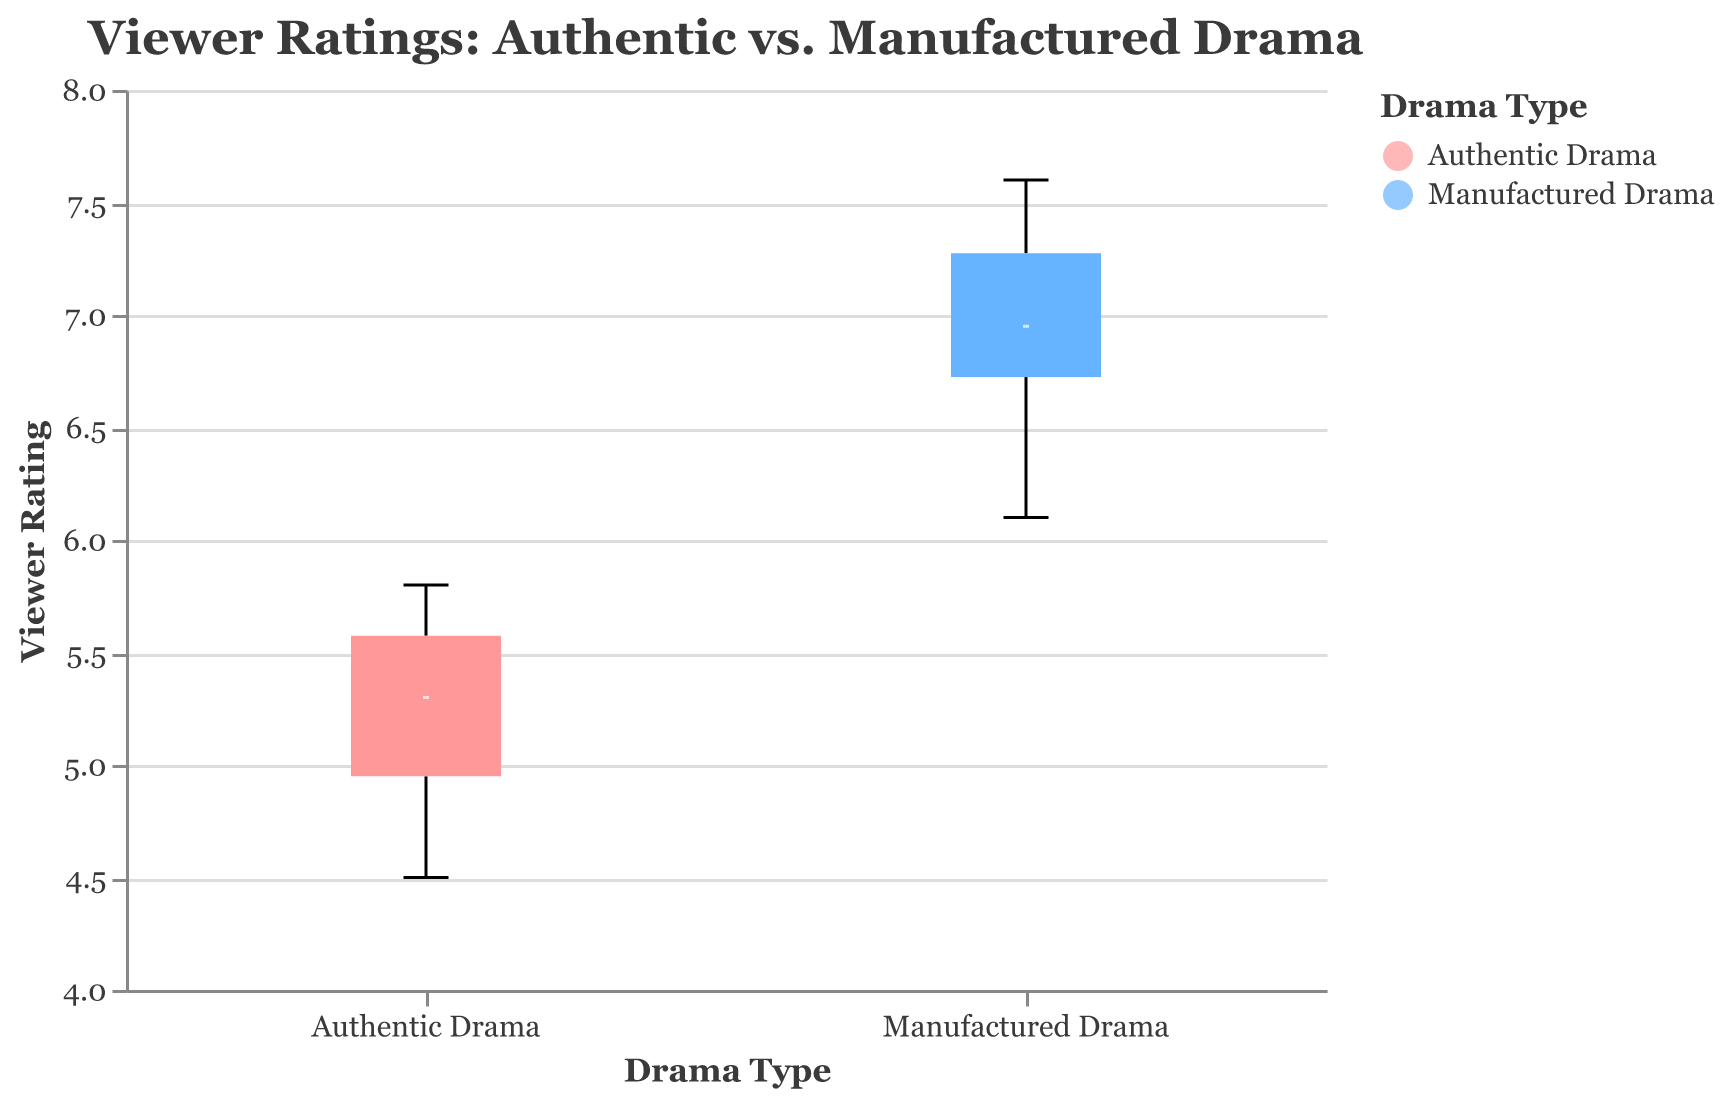What's the title of the box plot? The title is located at the top of the visualization.
Answer: Viewer Ratings: Authentic vs. Manufactured Drama What do the colors in the box plot represent? The legend indicates that the colors differentiate between "Authentic Drama" and "Manufactured Drama".
Answer: The colors represent "Authentic Drama" and "Manufactured Drama" Which group has the higher median viewer rating? The box plot's median lines represent this information. The median line for "Manufactured Drama" is higher than that for "Authentic Drama".
Answer: "Manufactured Drama" What's the minimum viewer rating for episodes featuring authentic drama? The minimum viewer rating is the lowest end of the whisker for "Authentic Drama".
Answer: 4.5 Which group shows a larger spread in viewer ratings? The spread is determined by the range from the minimum to maximum values in the box plots. "Manufactured Drama" has a wider range.
Answer: "Manufactured Drama" What is the interquartile range (IQR) for episodes featuring manufactured drama? The IQR is the range between the first quartile and third quartile in the box plot for "Manufactured Drama". The exact values can be estimated from the plot.
Answer: Approximately 1.9 (from ~6.4 to ~8.3) How do the maximum viewer ratings compare between the two drama types? The maximum viewer ratings are represented by the top ends of the whiskers. "Manufactured Drama" has a higher maximum than "Authentic Drama".
Answer: "Manufactured Drama" has a higher maximum What does the difference between the median viewer ratings of the two groups indicate about viewer preferences? The medians suggest that "Manufactured Drama" tends to have higher ratings on average, possibly indicating a preference for this type of drama.
Answer: Viewer preference leans towards "Manufactured Drama" Is there any overlap in the interquartile ranges (IQRs) of the two groups? Check if the boxes representing the IQRs overlap each other. The IQRs for "Authentic Drama" and "Manufactured Drama" do not overlap.
Answer: No overlap 